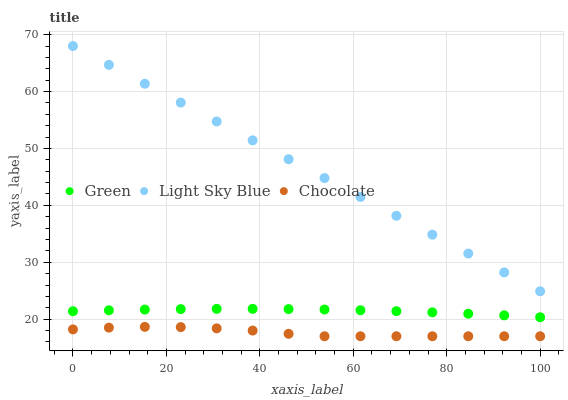Does Chocolate have the minimum area under the curve?
Answer yes or no. Yes. Does Light Sky Blue have the maximum area under the curve?
Answer yes or no. Yes. Does Green have the minimum area under the curve?
Answer yes or no. No. Does Green have the maximum area under the curve?
Answer yes or no. No. Is Light Sky Blue the smoothest?
Answer yes or no. Yes. Is Chocolate the roughest?
Answer yes or no. Yes. Is Green the smoothest?
Answer yes or no. No. Is Green the roughest?
Answer yes or no. No. Does Chocolate have the lowest value?
Answer yes or no. Yes. Does Green have the lowest value?
Answer yes or no. No. Does Light Sky Blue have the highest value?
Answer yes or no. Yes. Does Green have the highest value?
Answer yes or no. No. Is Chocolate less than Light Sky Blue?
Answer yes or no. Yes. Is Green greater than Chocolate?
Answer yes or no. Yes. Does Chocolate intersect Light Sky Blue?
Answer yes or no. No. 